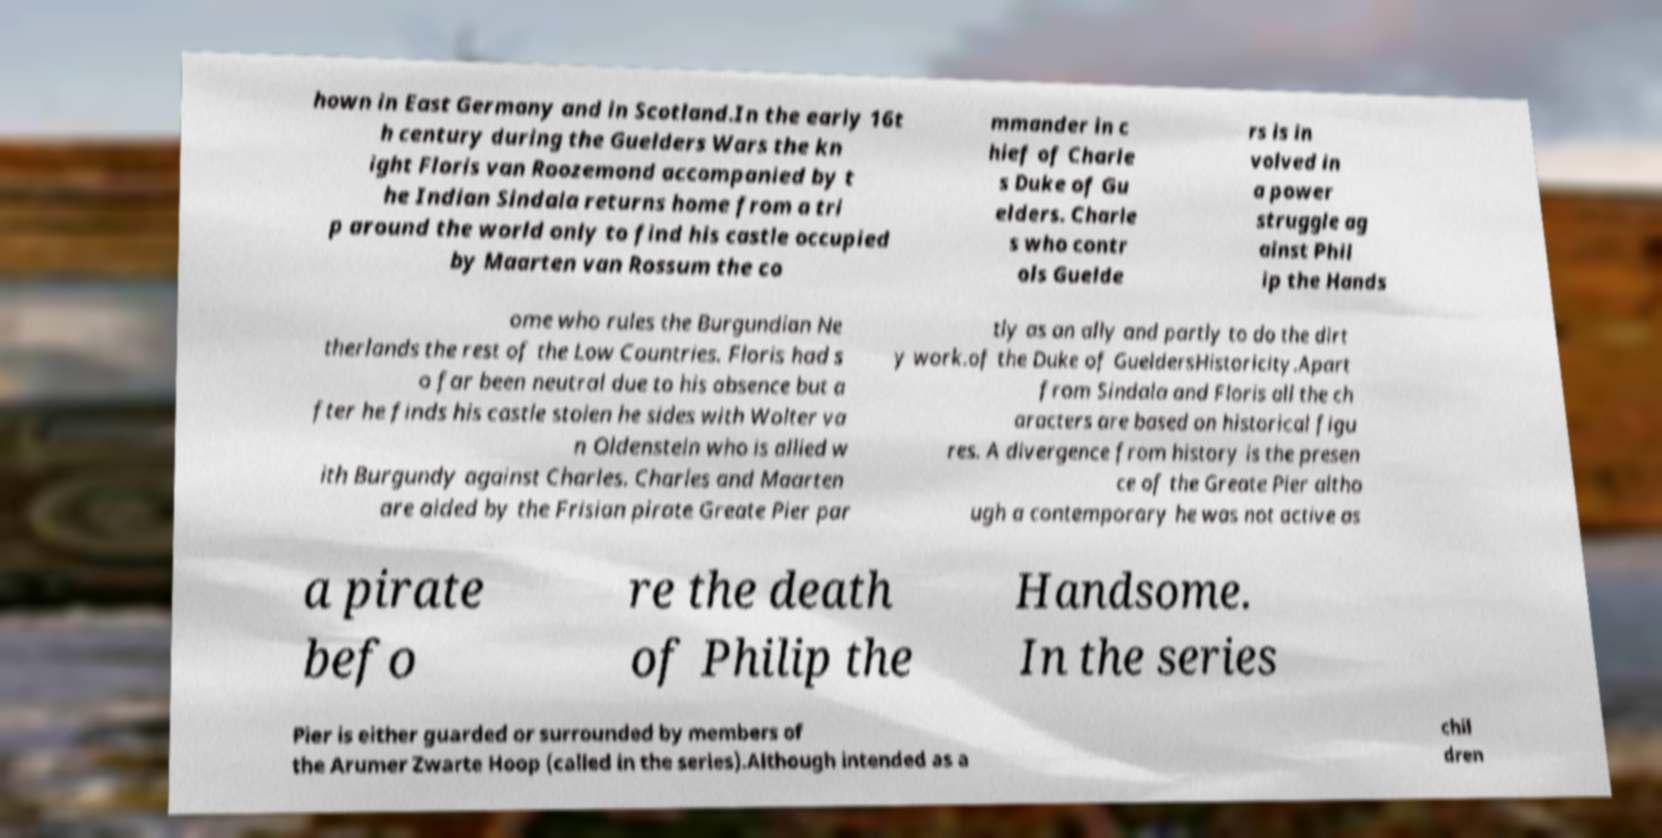What messages or text are displayed in this image? I need them in a readable, typed format. hown in East Germany and in Scotland.In the early 16t h century during the Guelders Wars the kn ight Floris van Roozemond accompanied by t he Indian Sindala returns home from a tri p around the world only to find his castle occupied by Maarten van Rossum the co mmander in c hief of Charle s Duke of Gu elders. Charle s who contr ols Guelde rs is in volved in a power struggle ag ainst Phil ip the Hands ome who rules the Burgundian Ne therlands the rest of the Low Countries. Floris had s o far been neutral due to his absence but a fter he finds his castle stolen he sides with Wolter va n Oldenstein who is allied w ith Burgundy against Charles. Charles and Maarten are aided by the Frisian pirate Greate Pier par tly as an ally and partly to do the dirt y work.of the Duke of GueldersHistoricity.Apart from Sindala and Floris all the ch aracters are based on historical figu res. A divergence from history is the presen ce of the Greate Pier altho ugh a contemporary he was not active as a pirate befo re the death of Philip the Handsome. In the series Pier is either guarded or surrounded by members of the Arumer Zwarte Hoop (called in the series).Although intended as a chil dren 